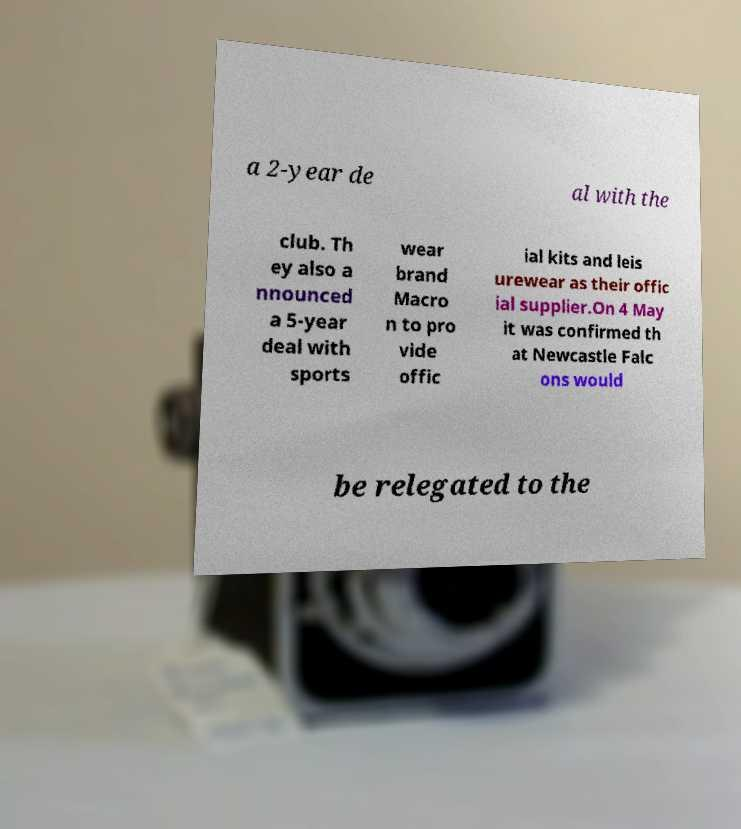Can you accurately transcribe the text from the provided image for me? a 2-year de al with the club. Th ey also a nnounced a 5-year deal with sports wear brand Macro n to pro vide offic ial kits and leis urewear as their offic ial supplier.On 4 May it was confirmed th at Newcastle Falc ons would be relegated to the 